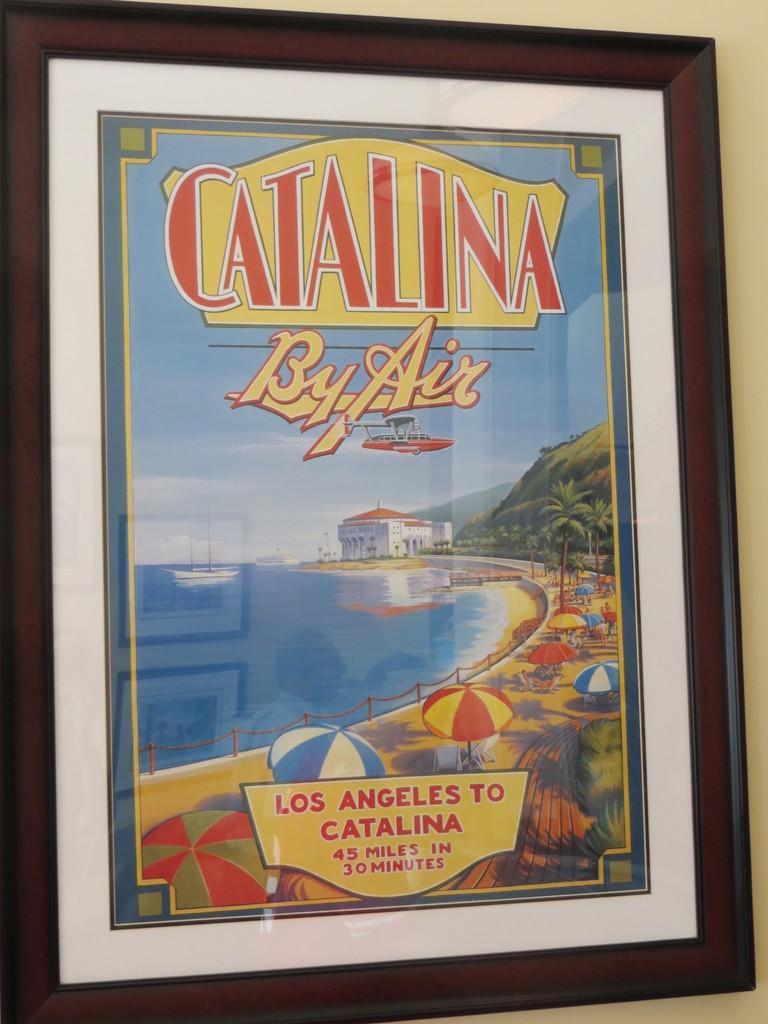How would you summarize this image in a sentence or two? In this picture I can see a frame of a poster placed to the wall. 